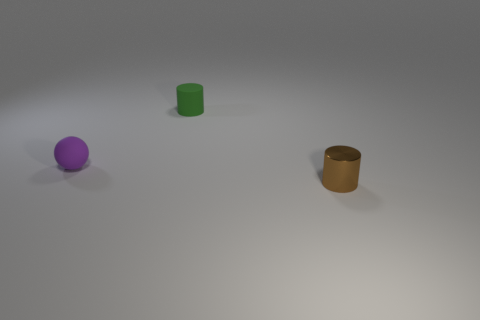Add 3 matte blocks. How many objects exist? 6 Subtract all cylinders. How many objects are left? 1 Add 2 green cylinders. How many green cylinders are left? 3 Add 3 tiny matte spheres. How many tiny matte spheres exist? 4 Subtract 0 gray blocks. How many objects are left? 3 Subtract all tiny things. Subtract all large purple balls. How many objects are left? 0 